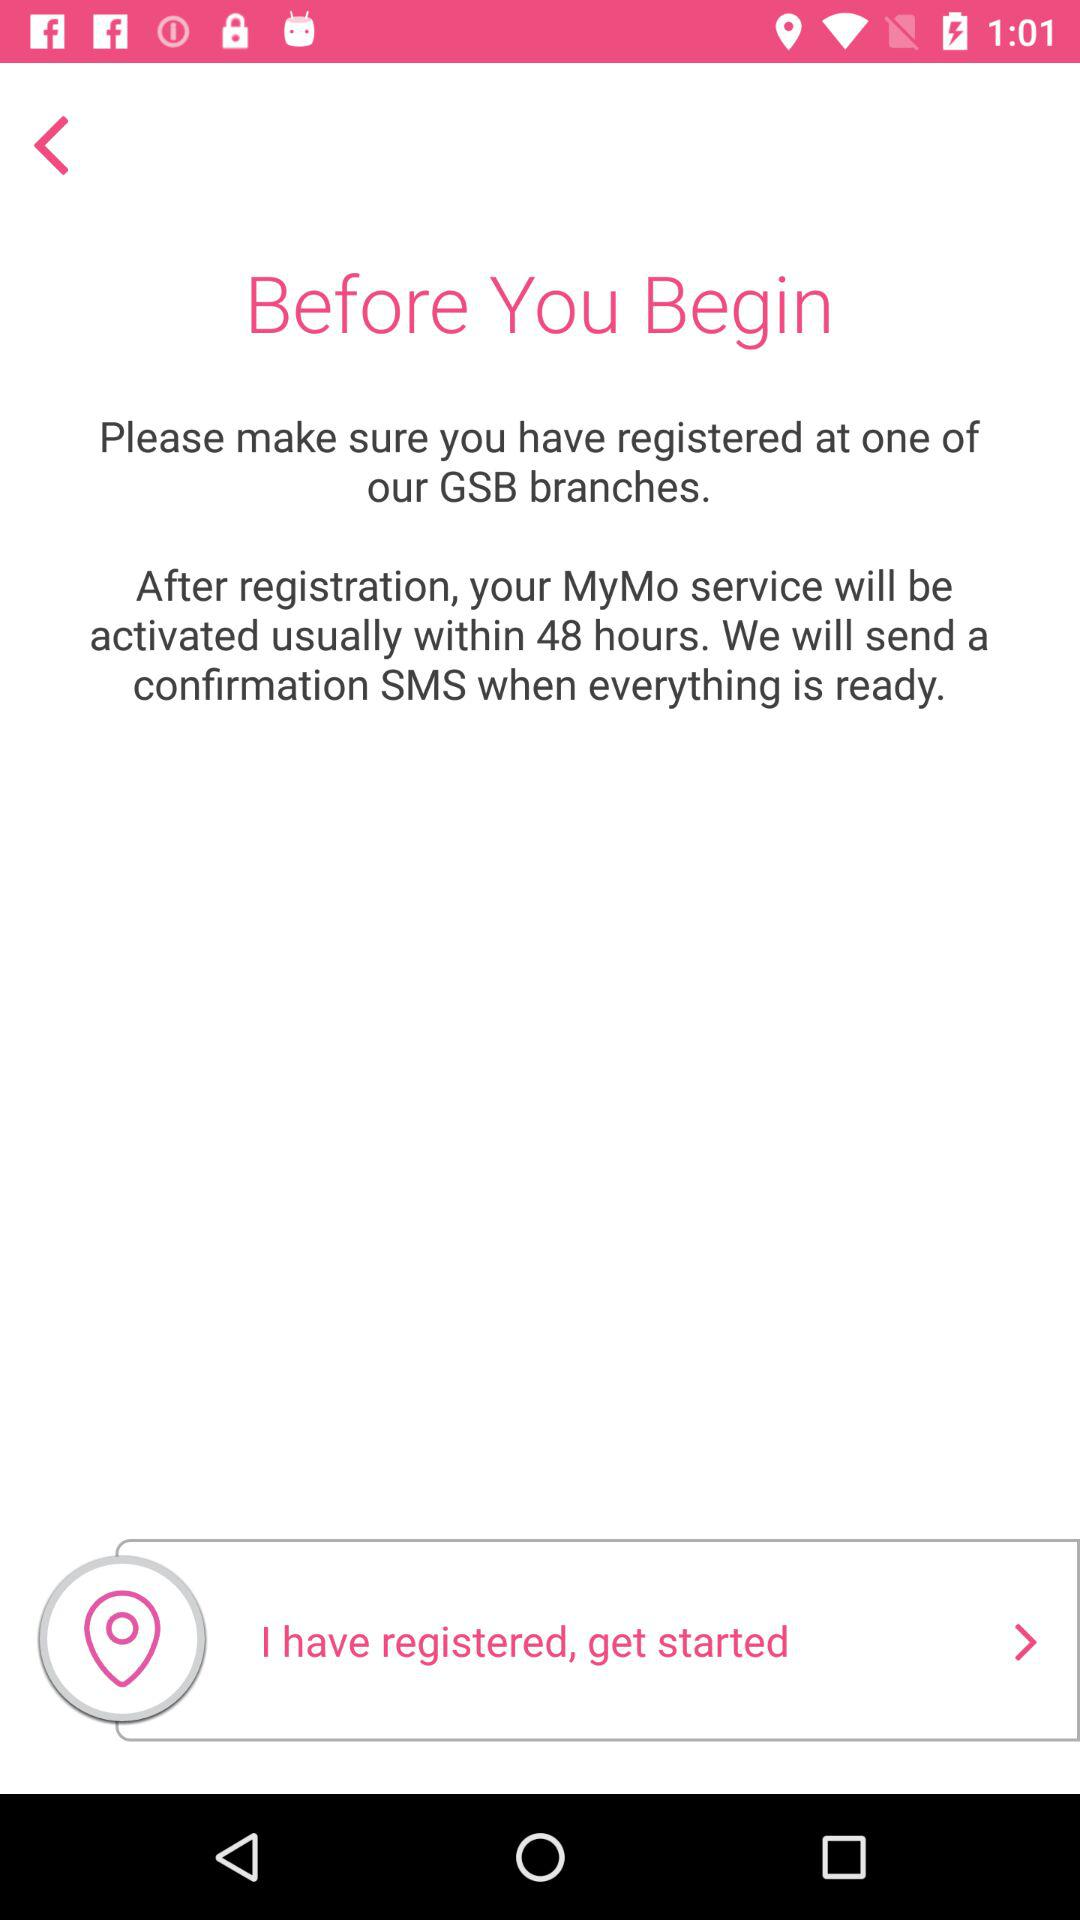When will the service be activated after registration? After registration, the service will be activated within 48 hours. 